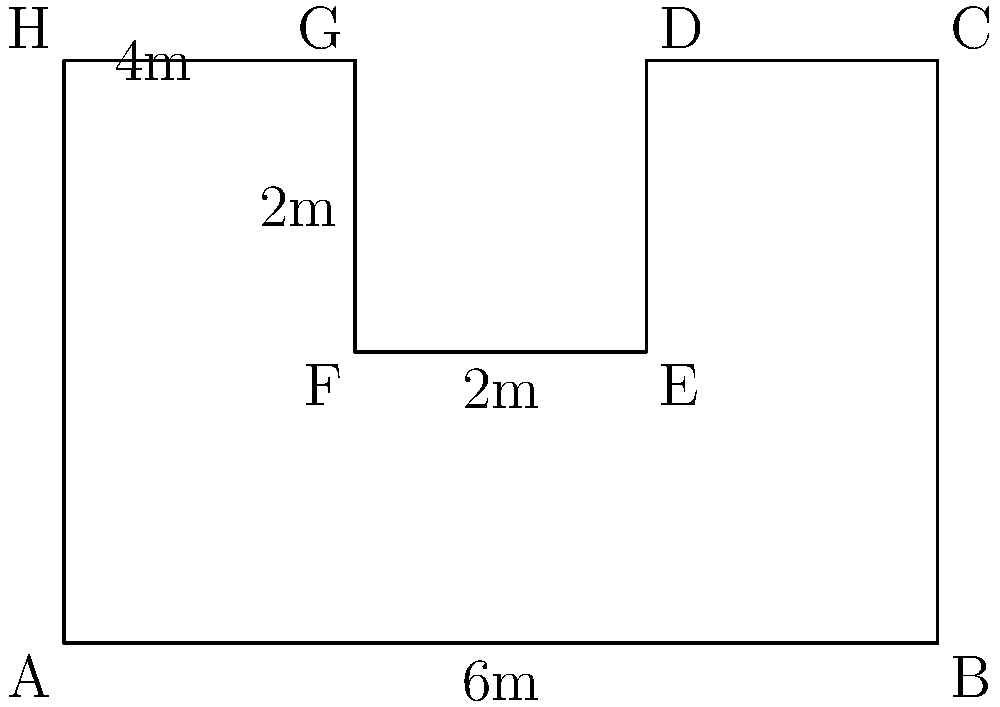Your shared living space has an irregular shape as shown in the diagram. Calculate the total usable floor area of this space, which you use for practicing and performing your rap. All measurements are in meters. To calculate the area of this irregular polygon, we can divide it into rectangles and add their areas:

1. First, identify the rectangles:
   - Rectangle 1: ABCH (main area)
   - Rectangle 2: DEFG (cutout area)

2. Calculate the area of Rectangle 1 (ABCH):
   $A_1 = 6m \times 4m = 24m^2$

3. Calculate the area of Rectangle 2 (DEFG):
   $A_2 = 2m \times 2m = 4m^2$

4. The total usable area is the difference between these two areas:
   $A_{total} = A_1 - A_2 = 24m^2 - 4m^2 = 20m^2$

Therefore, the total usable floor area of your shared living space for rap practice and performance is $20m^2$.
Answer: $20m^2$ 